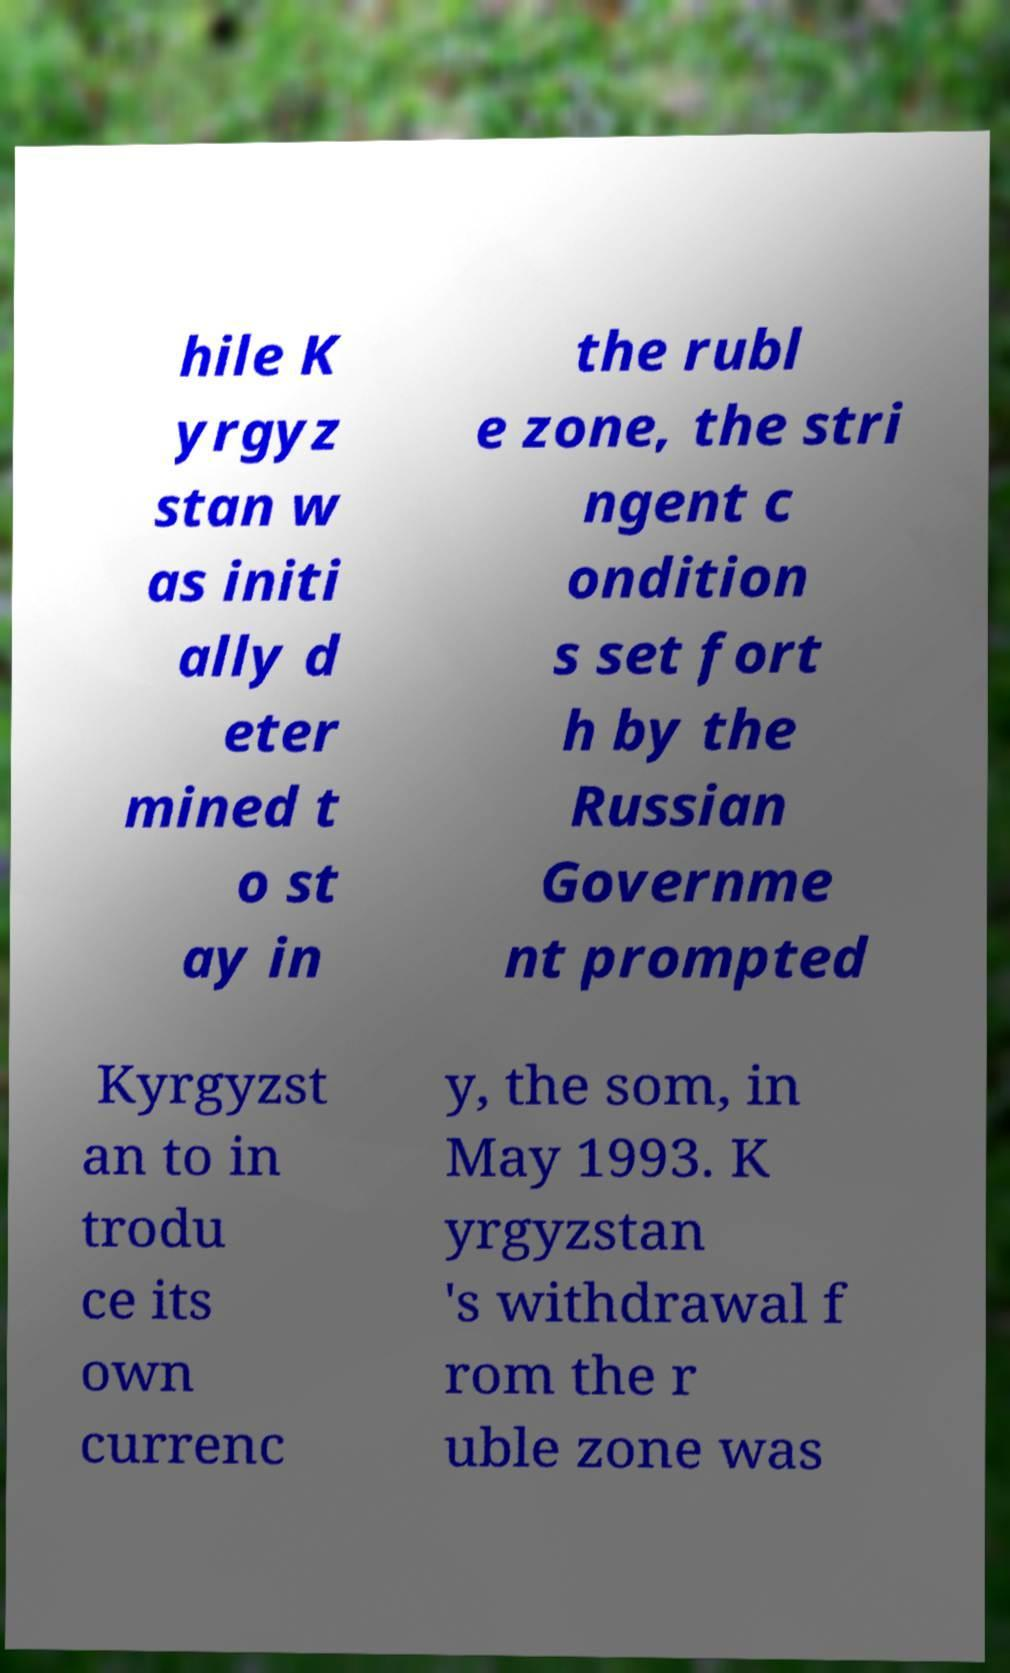Could you assist in decoding the text presented in this image and type it out clearly? hile K yrgyz stan w as initi ally d eter mined t o st ay in the rubl e zone, the stri ngent c ondition s set fort h by the Russian Governme nt prompted Kyrgyzst an to in trodu ce its own currenc y, the som, in May 1993. K yrgyzstan 's withdrawal f rom the r uble zone was 